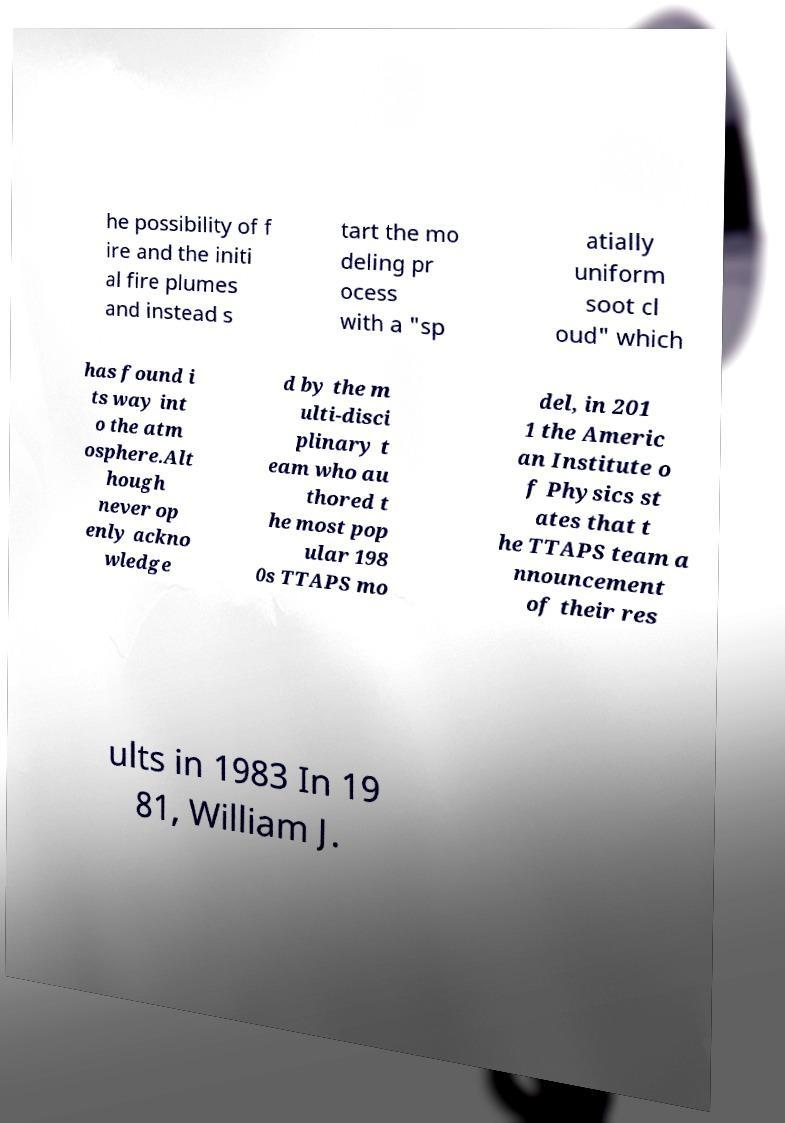For documentation purposes, I need the text within this image transcribed. Could you provide that? he possibility of f ire and the initi al fire plumes and instead s tart the mo deling pr ocess with a "sp atially uniform soot cl oud" which has found i ts way int o the atm osphere.Alt hough never op enly ackno wledge d by the m ulti-disci plinary t eam who au thored t he most pop ular 198 0s TTAPS mo del, in 201 1 the Americ an Institute o f Physics st ates that t he TTAPS team a nnouncement of their res ults in 1983 In 19 81, William J. 